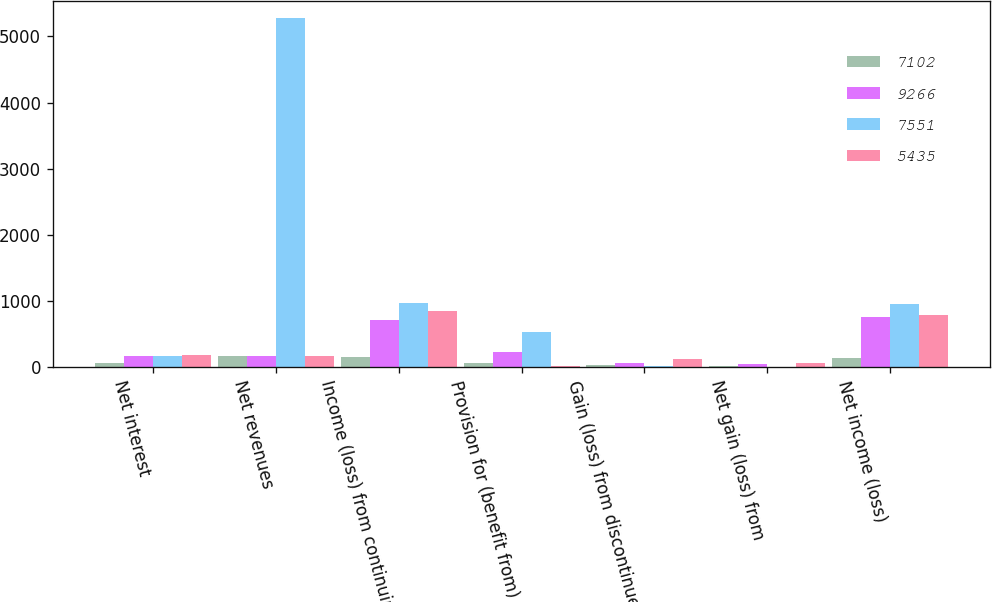Convert chart. <chart><loc_0><loc_0><loc_500><loc_500><stacked_bar_chart><ecel><fcel>Net interest<fcel>Net revenues<fcel>Income (loss) from continuing<fcel>Provision for (benefit from)<fcel>Gain (loss) from discontinued<fcel>Net gain (loss) from<fcel>Net income (loss)<nl><fcel>7102<fcel>59<fcel>160<fcel>148<fcel>54<fcel>28<fcel>14<fcel>134<nl><fcel>9266<fcel>160<fcel>160<fcel>713<fcel>224<fcel>52<fcel>37<fcel>750<nl><fcel>7551<fcel>155<fcel>5280<fcel>958<fcel>525<fcel>11<fcel>2<fcel>956<nl><fcel>5435<fcel>175<fcel>160<fcel>851<fcel>8<fcel>112<fcel>63<fcel>788<nl></chart> 